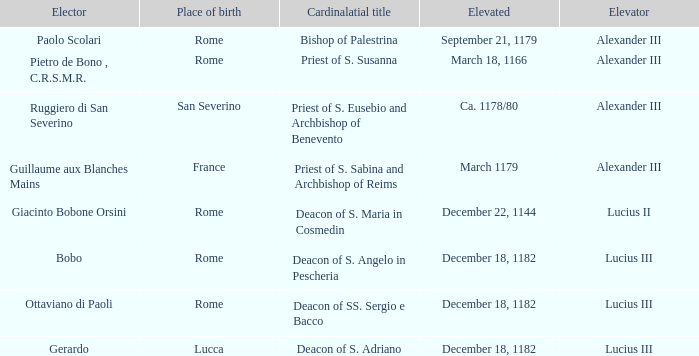What Elector has an Elevator of Alexander III and a Cardinalatial title of Bishop of Palestrina? Paolo Scolari. 